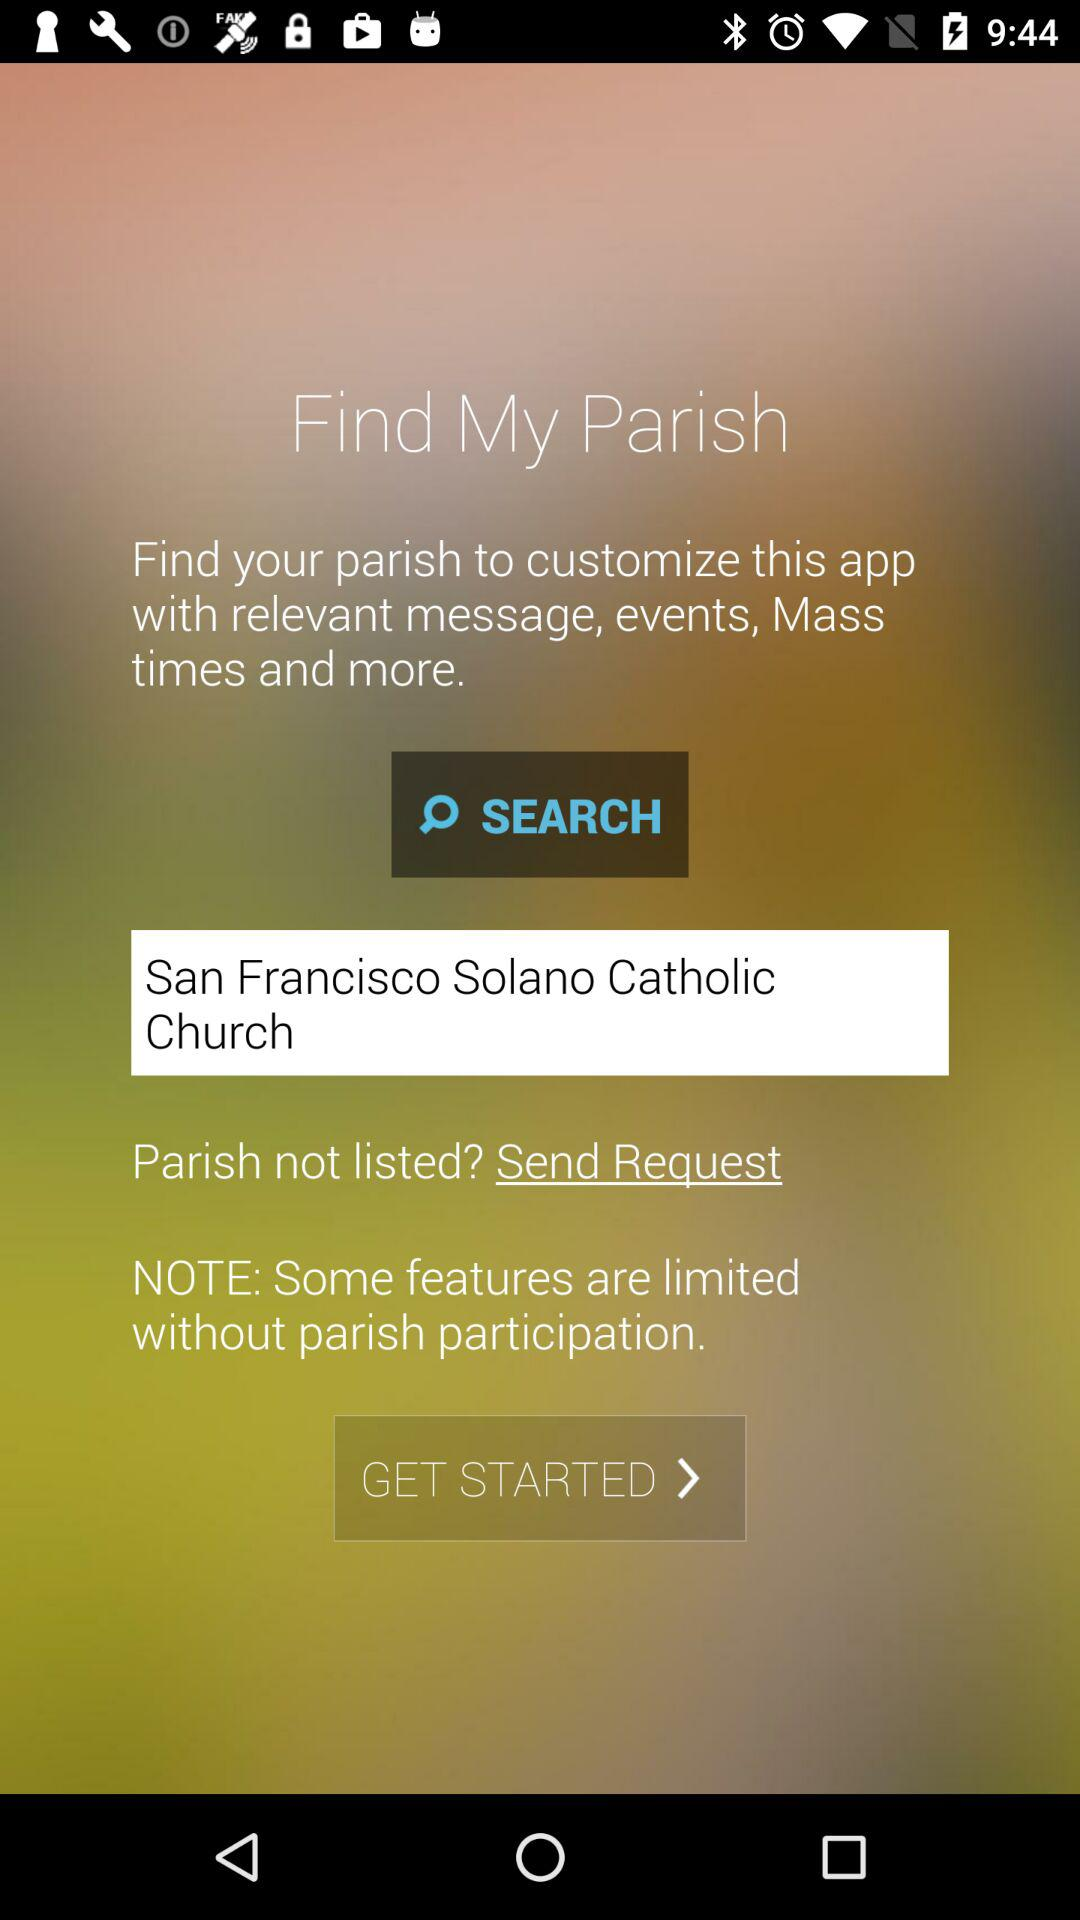What is the searched location? The searched location is San Francisco Solano Catholic Church. 